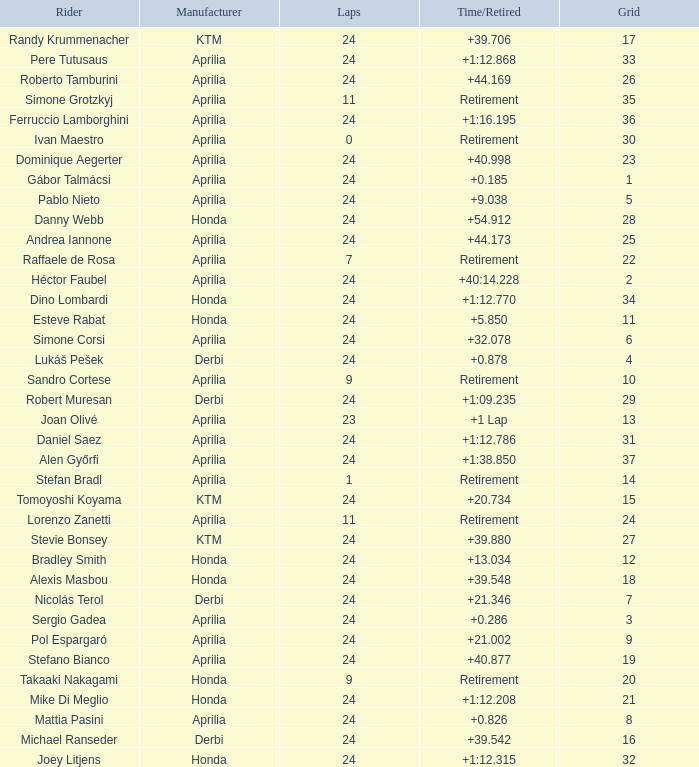Who manufactured the motorcycle that did 24 laps and 9 grids? Aprilia. Can you give me this table as a dict? {'header': ['Rider', 'Manufacturer', 'Laps', 'Time/Retired', 'Grid'], 'rows': [['Randy Krummenacher', 'KTM', '24', '+39.706', '17'], ['Pere Tutusaus', 'Aprilia', '24', '+1:12.868', '33'], ['Roberto Tamburini', 'Aprilia', '24', '+44.169', '26'], ['Simone Grotzkyj', 'Aprilia', '11', 'Retirement', '35'], ['Ferruccio Lamborghini', 'Aprilia', '24', '+1:16.195', '36'], ['Ivan Maestro', 'Aprilia', '0', 'Retirement', '30'], ['Dominique Aegerter', 'Aprilia', '24', '+40.998', '23'], ['Gábor Talmácsi', 'Aprilia', '24', '+0.185', '1'], ['Pablo Nieto', 'Aprilia', '24', '+9.038', '5'], ['Danny Webb', 'Honda', '24', '+54.912', '28'], ['Andrea Iannone', 'Aprilia', '24', '+44.173', '25'], ['Raffaele de Rosa', 'Aprilia', '7', 'Retirement', '22'], ['Héctor Faubel', 'Aprilia', '24', '+40:14.228', '2'], ['Dino Lombardi', 'Honda', '24', '+1:12.770', '34'], ['Esteve Rabat', 'Honda', '24', '+5.850', '11'], ['Simone Corsi', 'Aprilia', '24', '+32.078', '6'], ['Lukáš Pešek', 'Derbi', '24', '+0.878', '4'], ['Sandro Cortese', 'Aprilia', '9', 'Retirement', '10'], ['Robert Muresan', 'Derbi', '24', '+1:09.235', '29'], ['Joan Olivé', 'Aprilia', '23', '+1 Lap', '13'], ['Daniel Saez', 'Aprilia', '24', '+1:12.786', '31'], ['Alen Győrfi', 'Aprilia', '24', '+1:38.850', '37'], ['Stefan Bradl', 'Aprilia', '1', 'Retirement', '14'], ['Tomoyoshi Koyama', 'KTM', '24', '+20.734', '15'], ['Lorenzo Zanetti', 'Aprilia', '11', 'Retirement', '24'], ['Stevie Bonsey', 'KTM', '24', '+39.880', '27'], ['Bradley Smith', 'Honda', '24', '+13.034', '12'], ['Alexis Masbou', 'Honda', '24', '+39.548', '18'], ['Nicolás Terol', 'Derbi', '24', '+21.346', '7'], ['Sergio Gadea', 'Aprilia', '24', '+0.286', '3'], ['Pol Espargaró', 'Aprilia', '24', '+21.002', '9'], ['Stefano Bianco', 'Aprilia', '24', '+40.877', '19'], ['Takaaki Nakagami', 'Honda', '9', 'Retirement', '20'], ['Mike Di Meglio', 'Honda', '24', '+1:12.208', '21'], ['Mattia Pasini', 'Aprilia', '24', '+0.826', '8'], ['Michael Ranseder', 'Derbi', '24', '+39.542', '16'], ['Joey Litjens', 'Honda', '24', '+1:12.315', '32']]} 